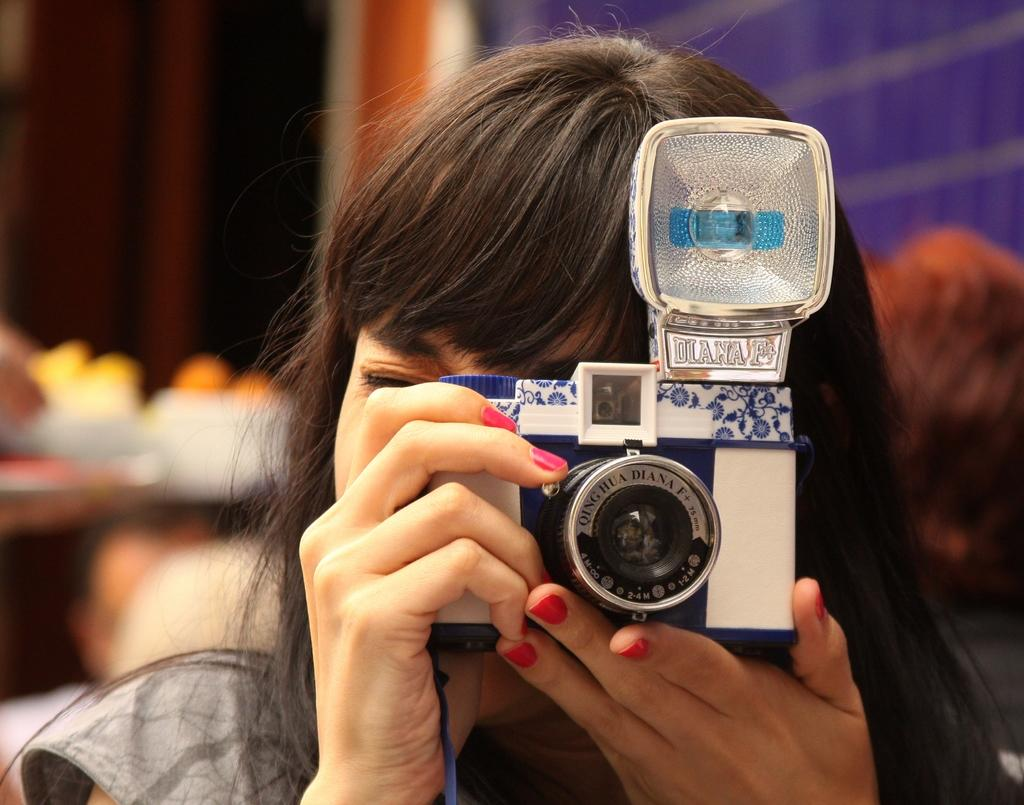<image>
Summarize the visual content of the image. A lady with red nail polish taking a photo with a camera that has Diana written on it. 